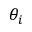Convert formula to latex. <formula><loc_0><loc_0><loc_500><loc_500>\theta _ { i }</formula> 